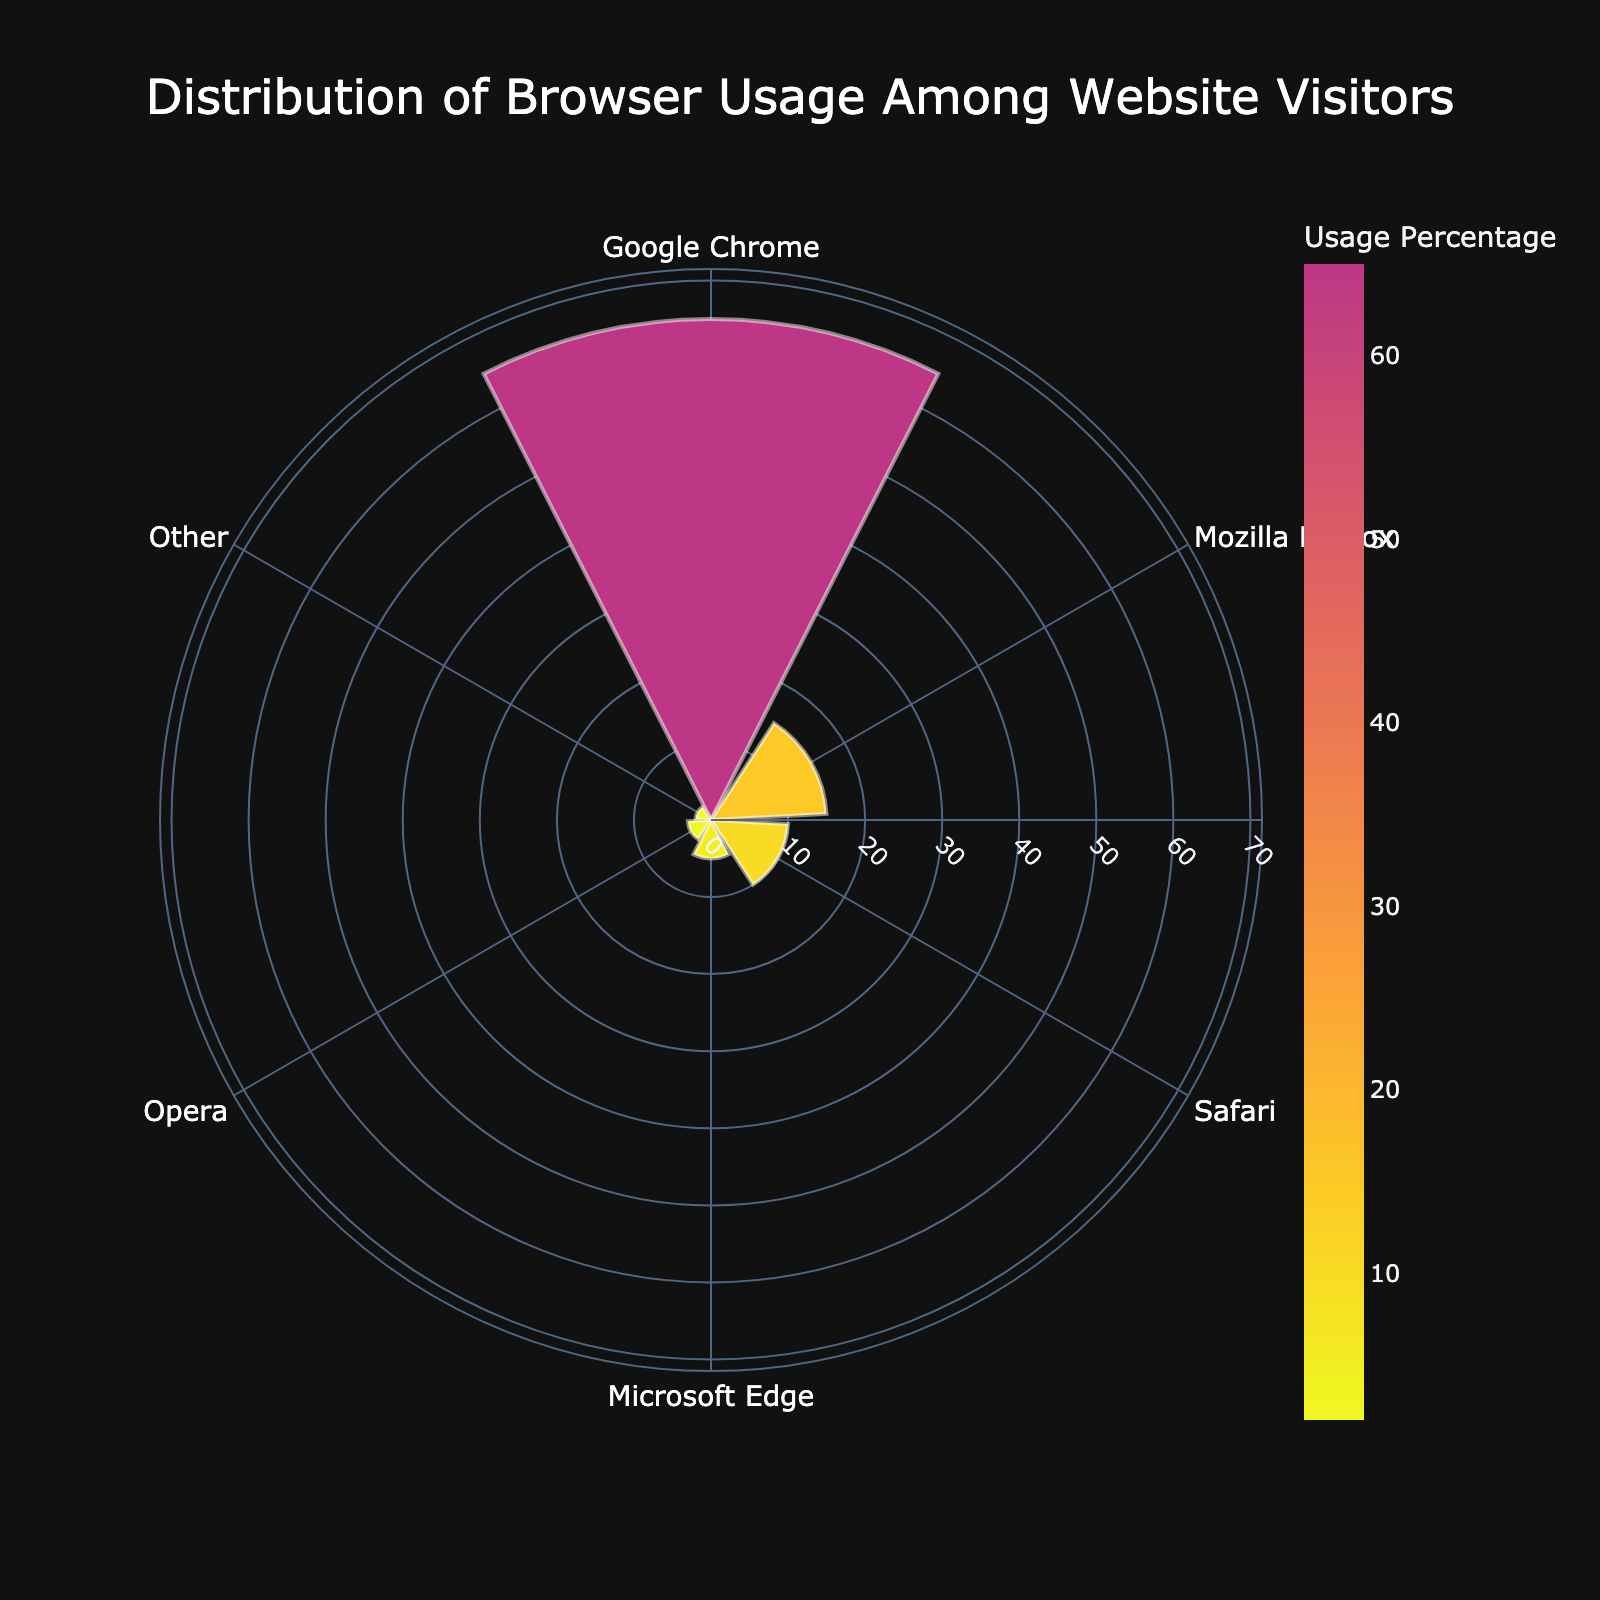What's the title of the polar area chart? The title is often prominently displayed at the top of the chart, providing a summary of the visual. Here, it is easily noticeable.
Answer: Distribution of Browser Usage Among Website Visitors How many different browsers are represented in the figure? Each segment of the polar area chart represents a different browser, and by counting these segments, you can determine the number of different browsers.
Answer: 6 Which browser has the highest usage percentage? The segment with the largest radius represents the highest usage percentage. By identifying and reading the label of this segment, we can find the answer.
Answer: Google Chrome What is the combined usage percentage for Safari and Microsoft Edge? To find the combined percentage, add the usage percentages of Safari and Microsoft Edge together: 10% for Safari and 5% for Microsoft Edge.
Answer: 15% How does Opera's usage compare to Firefox's usage? Compare the length of the segments (or the percentage values) for Opera and Firefox. Firefox has a significantly larger segment than Opera.
Answer: Firefox has a higher usage percentage than Opera What is the difference in usage percentage between the most and least used browsers? Subtract the usage percentage of the least used browser (2% for Other) from the most used browser (65% for Google Chrome).
Answer: 63% Which browsers have a usage percentage lower than 10%? Identify all segments where the usage percentage is less than 10%. These would be Microsoft Edge, Opera, and Other.
Answer: Microsoft Edge, Opera, Other What's unique about the angular axis in this chart? The angular axis organizes the data points (browsers) radially around the chart, and the labels are rotated to ensure readability, aligned in a clockwise direction.
Answer: Angular axis with browser labels rotated clockwise What's the median usage percentage? Arrange the usage percentages in ascending order: 2%, 3%, 5%, 10%, 15%, 65%. The median is the middle value in this list. Since there are an even number of values, the median is the average of the two middle values (7.5%).
Answer: 7.5% What color is used for Google Chrome's segment? The custom color scale created from Plasma_r colors each segment uniquely. Google Chrome, having the highest value, likely uses the first color in the sequential palette, which could vary slightly but is distinct.
Answer: A shade from the Plasma_r palette, typically bright and prominent 